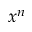Convert formula to latex. <formula><loc_0><loc_0><loc_500><loc_500>x ^ { n }</formula> 